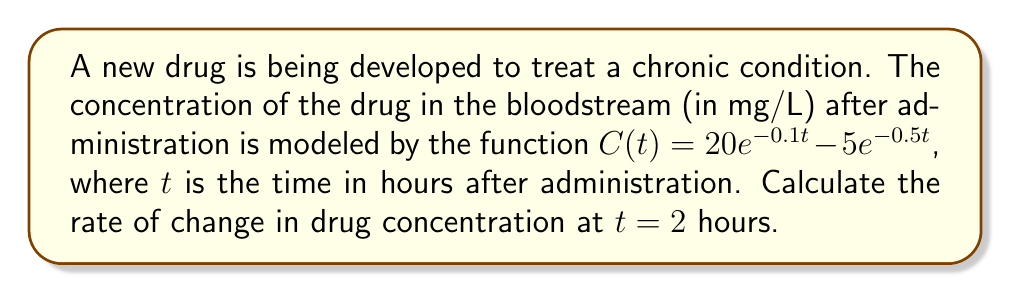Provide a solution to this math problem. To solve this problem, we need to find the derivative of the concentration function $C(t)$ and then evaluate it at $t = 2$ hours. Let's break it down step-by-step:

1) The concentration function is given as:
   $C(t) = 20e^{-0.1t} - 5e^{-0.5t}$

2) To find the rate of change, we need to differentiate $C(t)$ with respect to $t$:
   $$\frac{dC}{dt} = \frac{d}{dt}(20e^{-0.1t} - 5e^{-0.5t})$$

3) Using the chain rule, we get:
   $$\frac{dC}{dt} = 20 \cdot (-0.1) \cdot e^{-0.1t} - 5 \cdot (-0.5) \cdot e^{-0.5t}$$

4) Simplifying:
   $$\frac{dC}{dt} = -2e^{-0.1t} + 2.5e^{-0.5t}$$

5) Now, we need to evaluate this at $t = 2$:
   $$\left.\frac{dC}{dt}\right|_{t=2} = -2e^{-0.1(2)} + 2.5e^{-0.5(2)}$$

6) Calculating the exponentials:
   $$\left.\frac{dC}{dt}\right|_{t=2} = -2e^{-0.2} + 2.5e^{-1}$$

7) Evaluating:
   $$\left.\frac{dC}{dt}\right|_{t=2} = -2(0.8187) + 2.5(0.3679)$$
   $$\left.\frac{dC}{dt}\right|_{t=2} = -1.6374 + 0.9198$$
   $$\left.\frac{dC}{dt}\right|_{t=2} = -0.7176$$

The negative value indicates that the drug concentration is decreasing at $t = 2$ hours.
Answer: The rate of change in drug concentration at $t = 2$ hours is $-0.7176$ mg/L/hour. 